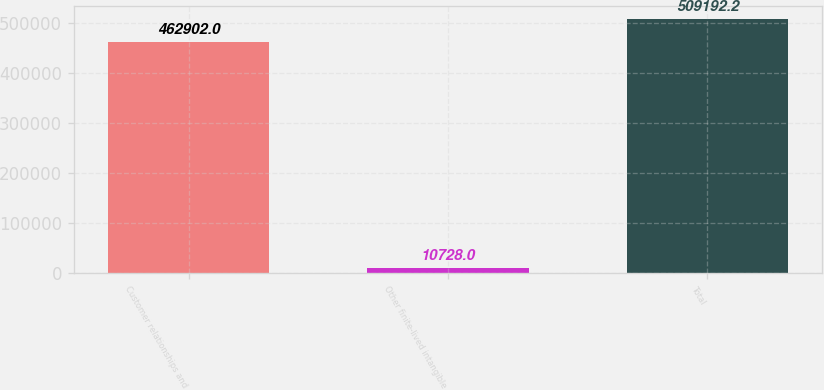Convert chart. <chart><loc_0><loc_0><loc_500><loc_500><bar_chart><fcel>Customer relationships and<fcel>Other finite-lived intangible<fcel>Total<nl><fcel>462902<fcel>10728<fcel>509192<nl></chart> 